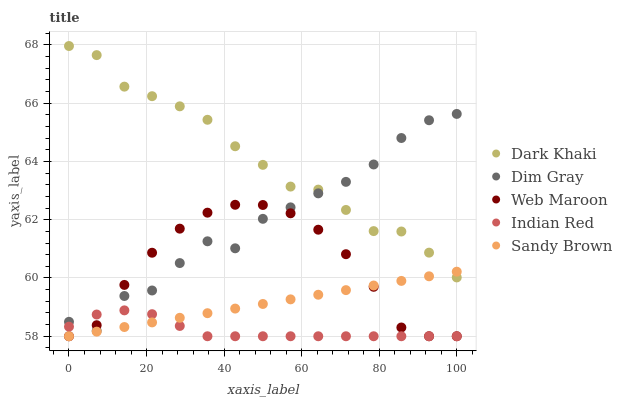Does Indian Red have the minimum area under the curve?
Answer yes or no. Yes. Does Dark Khaki have the maximum area under the curve?
Answer yes or no. Yes. Does Sandy Brown have the minimum area under the curve?
Answer yes or no. No. Does Sandy Brown have the maximum area under the curve?
Answer yes or no. No. Is Sandy Brown the smoothest?
Answer yes or no. Yes. Is Dim Gray the roughest?
Answer yes or no. Yes. Is Dim Gray the smoothest?
Answer yes or no. No. Is Sandy Brown the roughest?
Answer yes or no. No. Does Sandy Brown have the lowest value?
Answer yes or no. Yes. Does Dim Gray have the lowest value?
Answer yes or no. No. Does Dark Khaki have the highest value?
Answer yes or no. Yes. Does Sandy Brown have the highest value?
Answer yes or no. No. Is Web Maroon less than Dark Khaki?
Answer yes or no. Yes. Is Dark Khaki greater than Web Maroon?
Answer yes or no. Yes. Does Dark Khaki intersect Sandy Brown?
Answer yes or no. Yes. Is Dark Khaki less than Sandy Brown?
Answer yes or no. No. Is Dark Khaki greater than Sandy Brown?
Answer yes or no. No. Does Web Maroon intersect Dark Khaki?
Answer yes or no. No. 